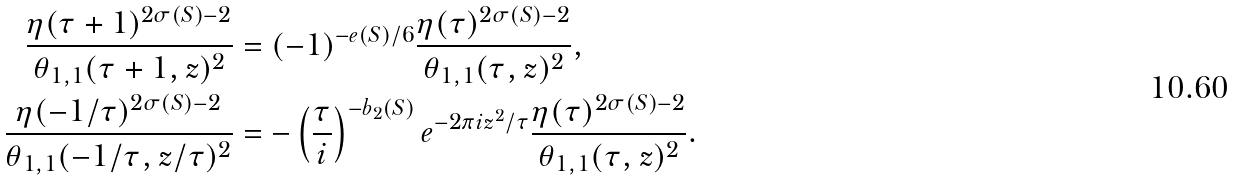<formula> <loc_0><loc_0><loc_500><loc_500>\frac { \eta ( \tau + 1 ) ^ { 2 \sigma ( S ) - 2 } } { \theta _ { 1 , 1 } ( \tau + 1 , z ) ^ { 2 } } & = ( - 1 ) ^ { - e ( S ) / 6 } \frac { \eta ( \tau ) ^ { 2 \sigma ( S ) - 2 } } { \theta _ { 1 , 1 } ( \tau , z ) ^ { 2 } } , \\ \frac { \eta ( - 1 / \tau ) ^ { 2 \sigma ( S ) - 2 } } { \theta _ { 1 , 1 } ( - 1 / \tau , z / \tau ) ^ { 2 } } & = - \left ( \frac { \tau } { i } \right ) ^ { - b _ { 2 } ( S ) } e ^ { - 2 \pi i z ^ { 2 } / \tau } \frac { \eta ( \tau ) ^ { 2 \sigma ( S ) - 2 } } { \theta _ { 1 , 1 } ( \tau , z ) ^ { 2 } } .</formula> 